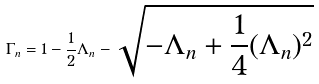Convert formula to latex. <formula><loc_0><loc_0><loc_500><loc_500>\Gamma _ { n } = 1 - \frac { 1 } { 2 } \Lambda _ { n } - \sqrt { - \Lambda _ { n } + \frac { 1 } { 4 } ( \Lambda _ { n } ) ^ { 2 } }</formula> 